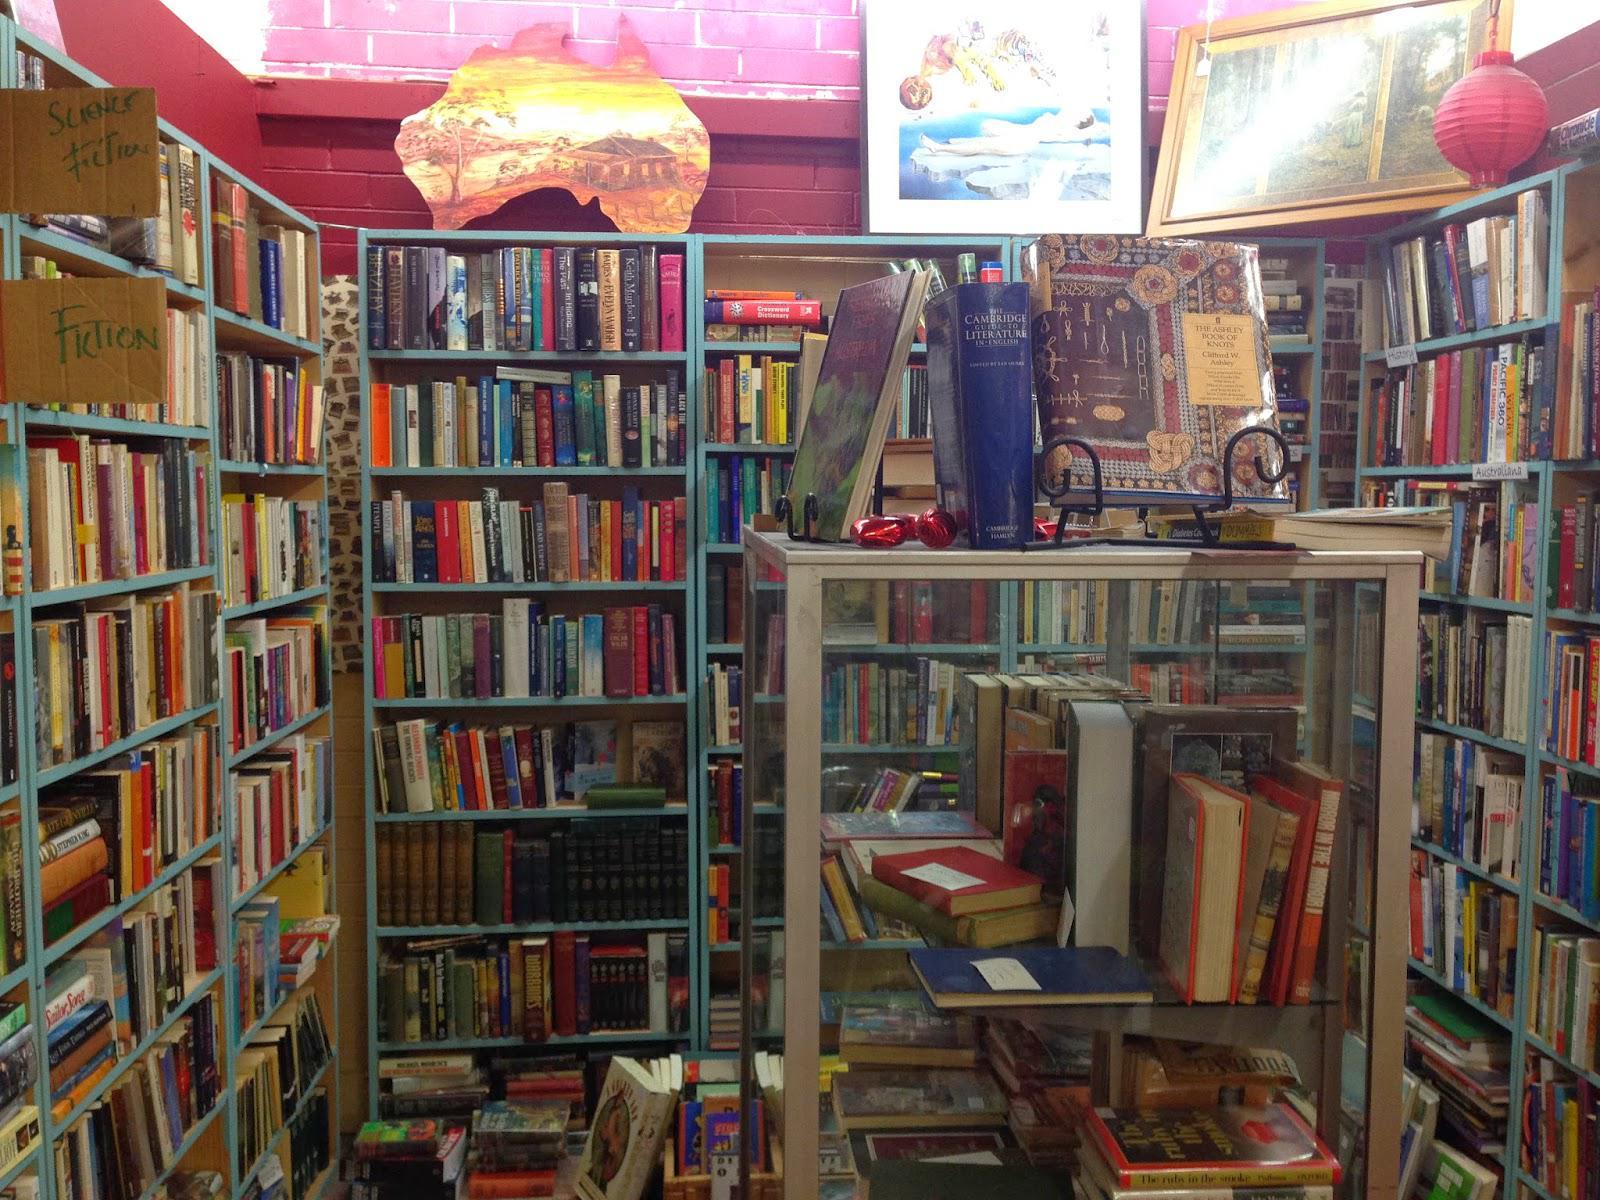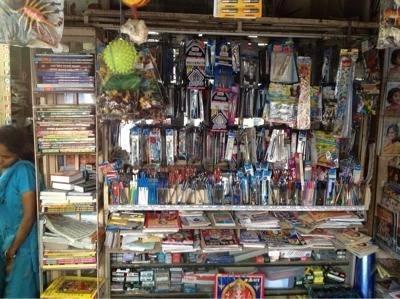The first image is the image on the left, the second image is the image on the right. For the images shown, is this caption "Black wires can be seen in one of the images." true? Answer yes or no. No. The first image is the image on the left, the second image is the image on the right. Assess this claim about the two images: "One of the images is of writing supplies, hanging on a wall.". Correct or not? Answer yes or no. Yes. 